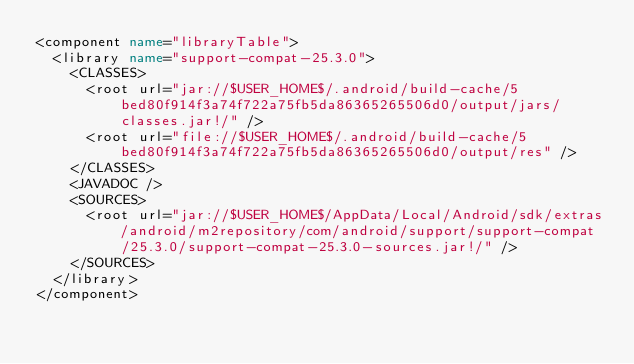<code> <loc_0><loc_0><loc_500><loc_500><_XML_><component name="libraryTable">
  <library name="support-compat-25.3.0">
    <CLASSES>
      <root url="jar://$USER_HOME$/.android/build-cache/5bed80f914f3a74f722a75fb5da86365265506d0/output/jars/classes.jar!/" />
      <root url="file://$USER_HOME$/.android/build-cache/5bed80f914f3a74f722a75fb5da86365265506d0/output/res" />
    </CLASSES>
    <JAVADOC />
    <SOURCES>
      <root url="jar://$USER_HOME$/AppData/Local/Android/sdk/extras/android/m2repository/com/android/support/support-compat/25.3.0/support-compat-25.3.0-sources.jar!/" />
    </SOURCES>
  </library>
</component></code> 